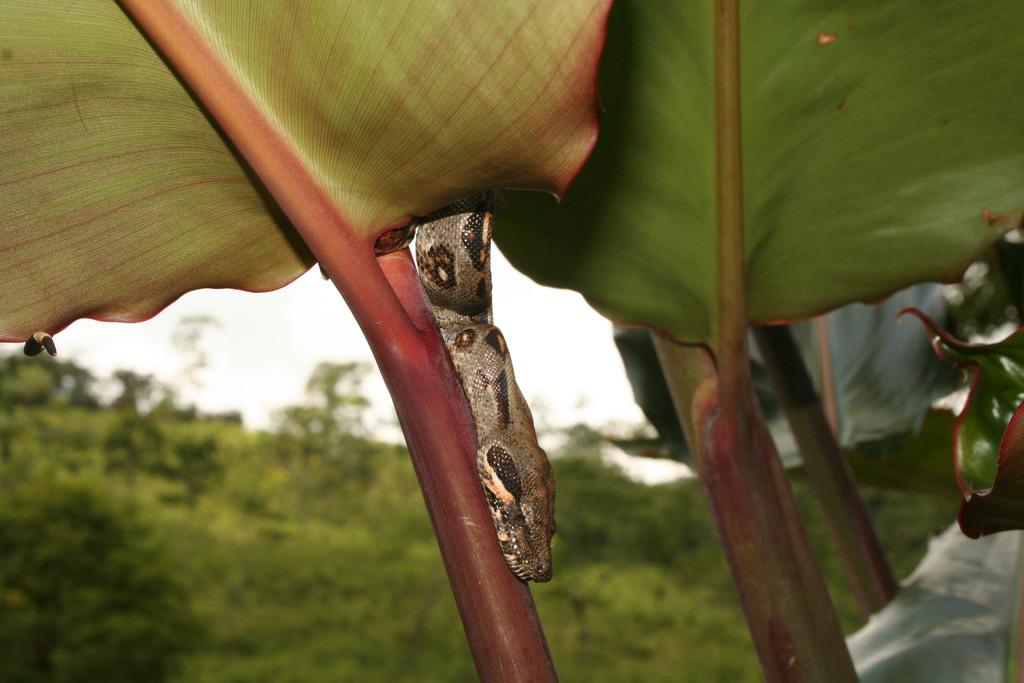What type of animal is in the image? There is a snake in the image. What other elements can be seen in the image besides the snake? There are leaves and a stem in the image. What is the color of the sky in the image? The sky is white in the image. How would you describe the background of the image? The background of the image is blurred. Can you see a cow drinking from a stream in the image? There is no cow or stream present in the image. 